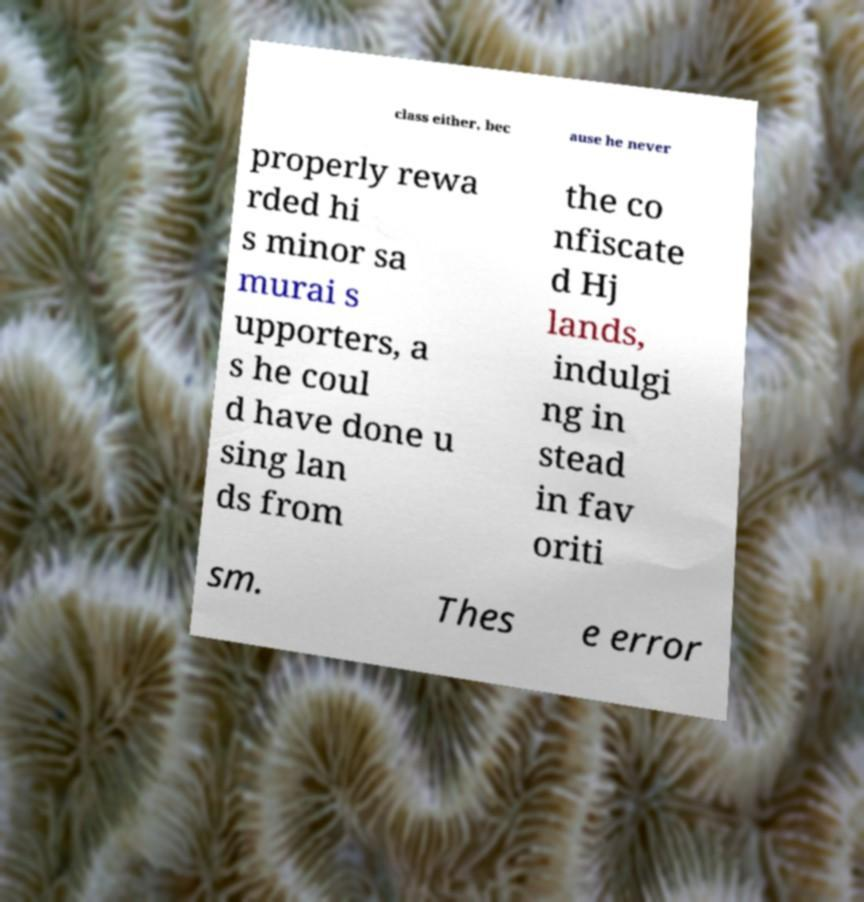For documentation purposes, I need the text within this image transcribed. Could you provide that? class either, bec ause he never properly rewa rded hi s minor sa murai s upporters, a s he coul d have done u sing lan ds from the co nfiscate d Hj lands, indulgi ng in stead in fav oriti sm. Thes e error 